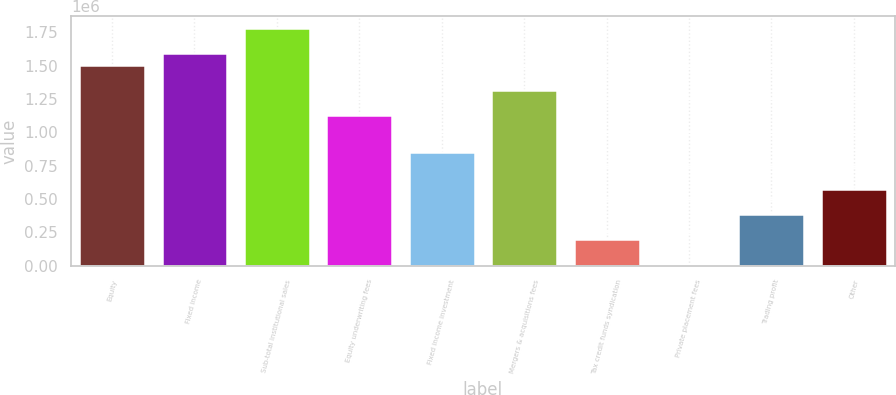Convert chart. <chart><loc_0><loc_0><loc_500><loc_500><bar_chart><fcel>Equity<fcel>Fixed income<fcel>Sub-total institutional sales<fcel>Equity underwriting fees<fcel>Fixed income investment<fcel>Mergers & acquisitions fees<fcel>Tax credit funds syndication<fcel>Private placement fees<fcel>Trading profit<fcel>Other<nl><fcel>1.50421e+06<fcel>1.59734e+06<fcel>1.78358e+06<fcel>1.13172e+06<fcel>852354<fcel>1.31797e+06<fcel>200495<fcel>14249<fcel>386740<fcel>572986<nl></chart> 